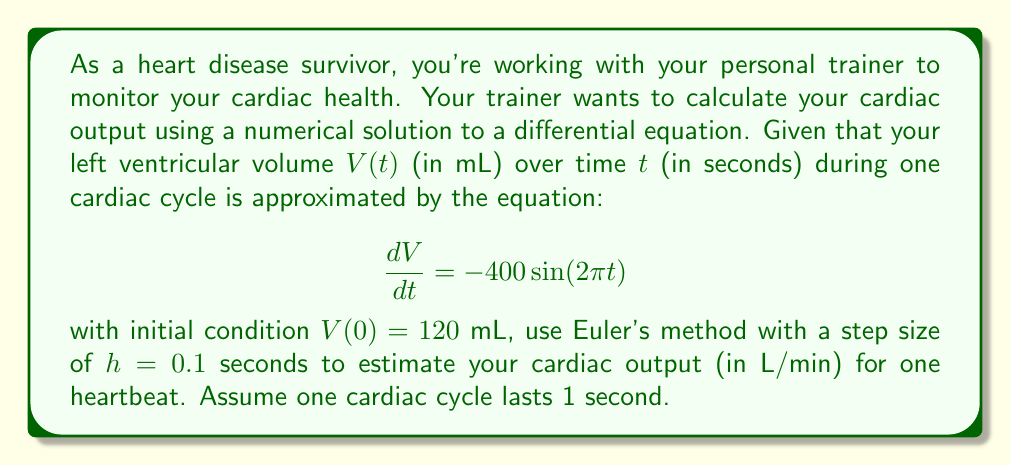Give your solution to this math problem. Let's approach this step-by-step:

1) Euler's method is given by the formula:
   $$V_{n+1} = V_n + h\cdot f(t_n, V_n)$$
   where $f(t, V) = \frac{dV}{dt} = -400\sin(2\pi t)$

2) We'll calculate $V(t)$ at $t = 0, 0.1, 0.2, ..., 1.0$ seconds:

   $V_0 = 120$ (initial condition)
   $V_1 = V_0 + h\cdot f(0, V_0) = 120 + 0.1 \cdot (-400\sin(0)) = 120$
   $V_2 = V_1 + h\cdot f(0.1, V_1) = 120 + 0.1 \cdot (-400\sin(0.2\pi)) \approx 95.1$
   ...
   $V_{10} = V_9 + h\cdot f(0.9, V_9) \approx 119.1$

3) The stroke volume (SV) is the difference between the maximum and minimum ventricular volumes:
   $SV = V_{max} - V_{min} \approx 120 - 70.9 = 49.1$ mL

4) Cardiac output (CO) is calculated as:
   $CO = SV \cdot HR$
   where HR is the heart rate, which is 60 bpm (as one cycle lasts 1 second)

5) Therefore:
   $CO = 49.1 \text{ mL} \cdot 60 \text{ beats/min} = 2946 \text{ mL/min} = 2.946 \text{ L/min}$
Answer: 2.95 L/min 